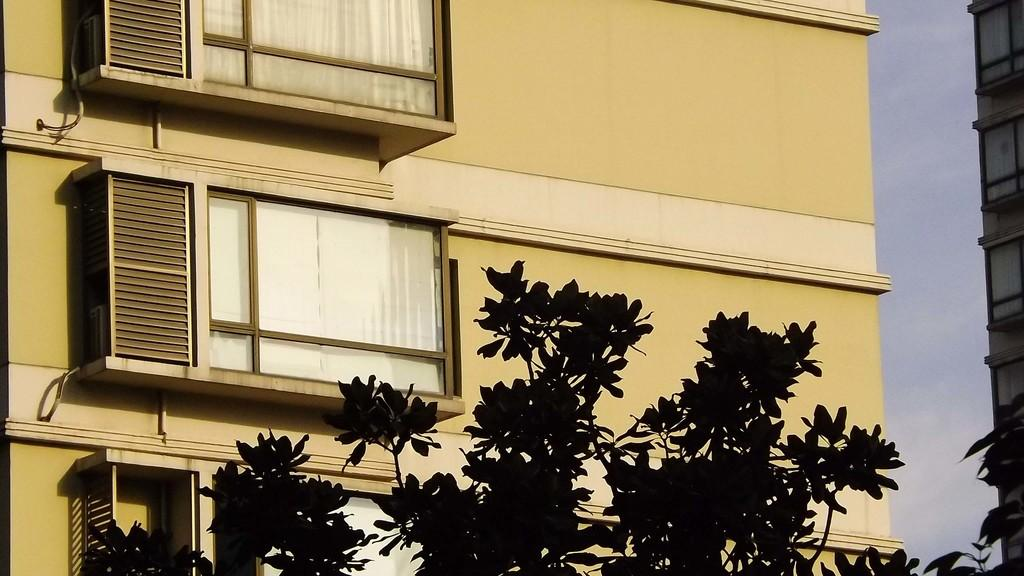What type of structures can be seen in the image? There are buildings in the image. What other natural elements are present in the image? There are trees in the image. What is visible in the background of the image? The sky is visible in the image. Can you describe the sky in the image? Clouds are present in the sky. How many people are attending the party in the image? There is no party present in the image. What type of hook can be seen attached to the buildings in the image? There are no hooks visible in the image; only buildings, trees, and the sky are present. 